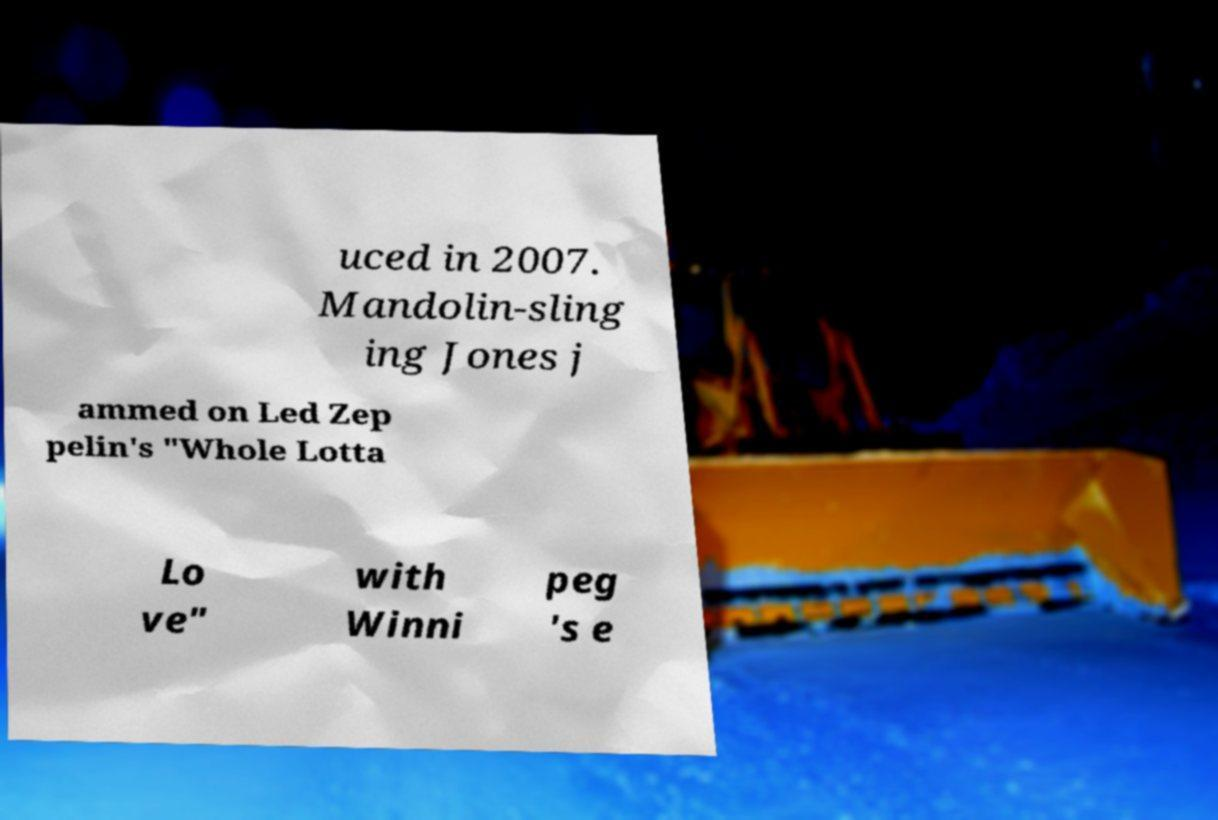Could you assist in decoding the text presented in this image and type it out clearly? uced in 2007. Mandolin-sling ing Jones j ammed on Led Zep pelin's "Whole Lotta Lo ve" with Winni peg 's e 